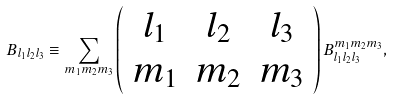Convert formula to latex. <formula><loc_0><loc_0><loc_500><loc_500>B _ { l _ { 1 } l _ { 2 } l _ { 3 } } \equiv \sum _ { m _ { 1 } m _ { 2 } m _ { 3 } } \left ( \begin{array} { c c c } l _ { 1 } & l _ { 2 } & l _ { 3 } \\ m _ { 1 } & m _ { 2 } & m _ { 3 } \end{array} \right ) B _ { l _ { 1 } l _ { 2 } l _ { 3 } } ^ { m _ { 1 } m _ { 2 } m _ { 3 } } ,</formula> 